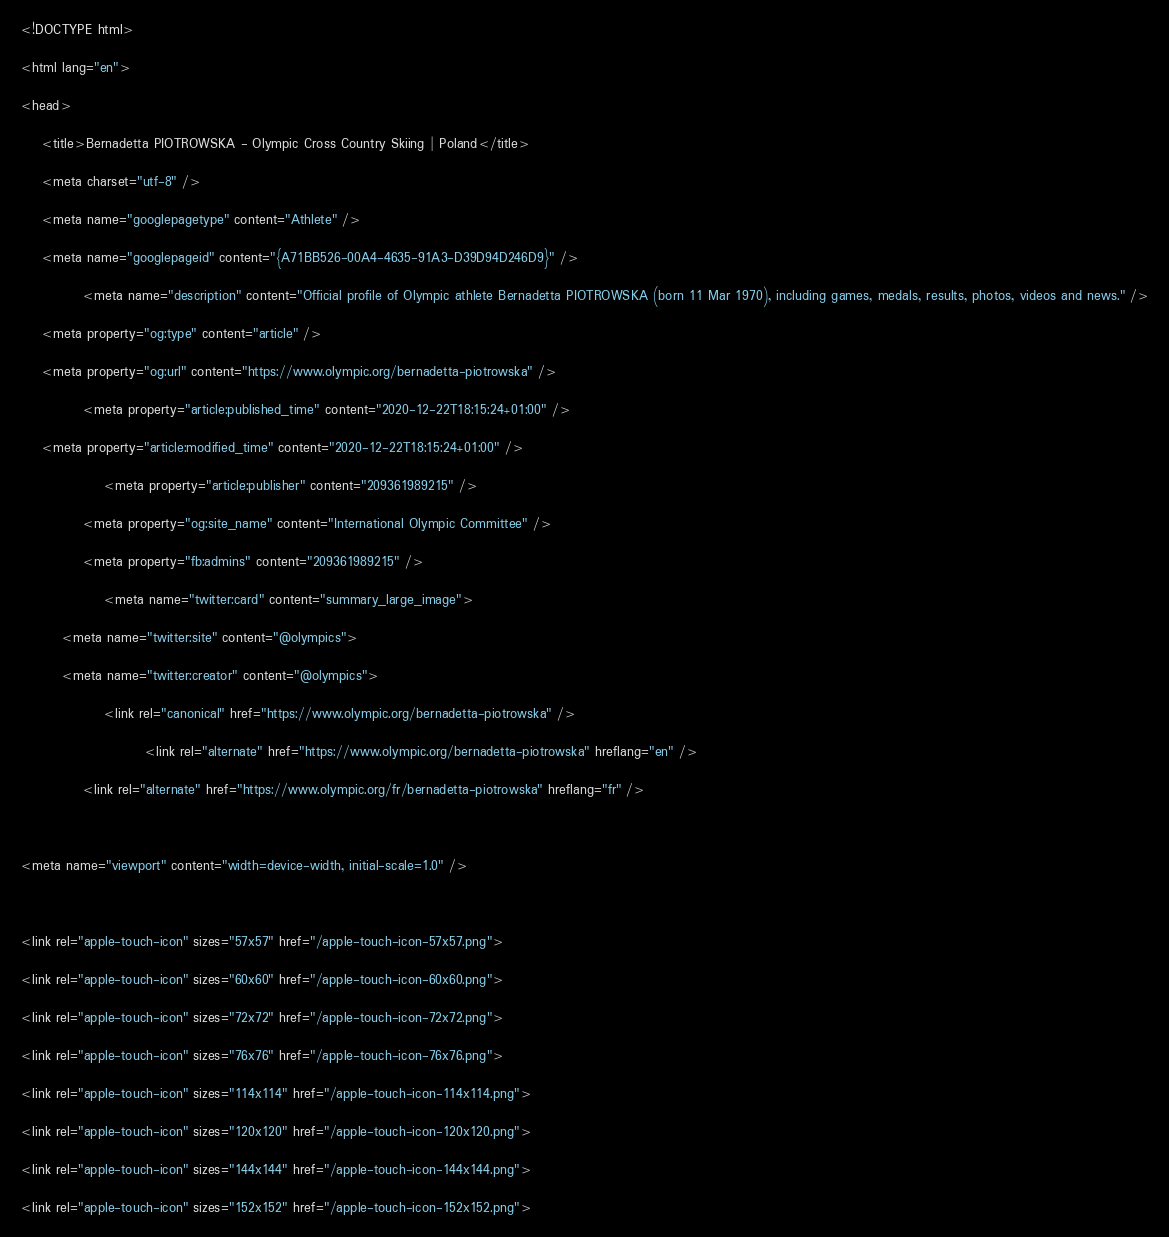Convert code to text. <code><loc_0><loc_0><loc_500><loc_500><_HTML_>

<!DOCTYPE html>
<html lang="en">
<head>
    <title>Bernadetta PIOTROWSKA - Olympic Cross Country Skiing | Poland</title>
    <meta charset="utf-8" />
    <meta name="googlepagetype" content="Athlete" />
    <meta name="googlepageid" content="{A71BB526-00A4-4635-91A3-D39D94D246D9}" />
            <meta name="description" content="Official profile of Olympic athlete Bernadetta PIOTROWSKA (born 11 Mar 1970), including games, medals, results, photos, videos and news." />
    <meta property="og:type" content="article" />
    <meta property="og:url" content="https://www.olympic.org/bernadetta-piotrowska" />
            <meta property="article:published_time" content="2020-12-22T18:15:24+01:00" />
    <meta property="article:modified_time" content="2020-12-22T18:15:24+01:00" />
                <meta property="article:publisher" content="209361989215" />
            <meta property="og:site_name" content="International Olympic Committee" />
            <meta property="fb:admins" content="209361989215" />
                <meta name="twitter:card" content="summary_large_image">
        <meta name="twitter:site" content="@olympics">
        <meta name="twitter:creator" content="@olympics">
                <link rel="canonical" href="https://www.olympic.org/bernadetta-piotrowska" />
                        <link rel="alternate" href="https://www.olympic.org/bernadetta-piotrowska" hreflang="en" />
            <link rel="alternate" href="https://www.olympic.org/fr/bernadetta-piotrowska" hreflang="fr" />
    
<meta name="viewport" content="width=device-width, initial-scale=1.0" />

<link rel="apple-touch-icon" sizes="57x57" href="/apple-touch-icon-57x57.png">
<link rel="apple-touch-icon" sizes="60x60" href="/apple-touch-icon-60x60.png">
<link rel="apple-touch-icon" sizes="72x72" href="/apple-touch-icon-72x72.png">
<link rel="apple-touch-icon" sizes="76x76" href="/apple-touch-icon-76x76.png">
<link rel="apple-touch-icon" sizes="114x114" href="/apple-touch-icon-114x114.png">
<link rel="apple-touch-icon" sizes="120x120" href="/apple-touch-icon-120x120.png">
<link rel="apple-touch-icon" sizes="144x144" href="/apple-touch-icon-144x144.png">
<link rel="apple-touch-icon" sizes="152x152" href="/apple-touch-icon-152x152.png"></code> 